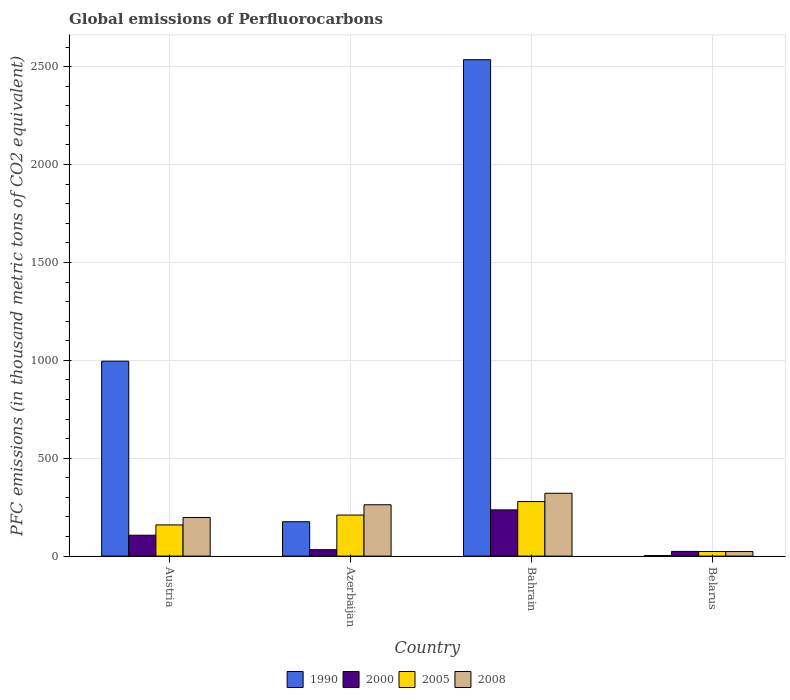Are the number of bars per tick equal to the number of legend labels?
Your answer should be very brief. Yes. How many bars are there on the 3rd tick from the right?
Your answer should be compact. 4. What is the label of the 4th group of bars from the left?
Provide a short and direct response. Belarus. In how many cases, is the number of bars for a given country not equal to the number of legend labels?
Make the answer very short. 0. What is the global emissions of Perfluorocarbons in 2008 in Azerbaijan?
Provide a short and direct response. 262.2. Across all countries, what is the maximum global emissions of Perfluorocarbons in 2008?
Offer a terse response. 320.9. Across all countries, what is the minimum global emissions of Perfluorocarbons in 2000?
Make the answer very short. 23.9. In which country was the global emissions of Perfluorocarbons in 1990 maximum?
Keep it short and to the point. Bahrain. In which country was the global emissions of Perfluorocarbons in 1990 minimum?
Provide a succinct answer. Belarus. What is the total global emissions of Perfluorocarbons in 2008 in the graph?
Ensure brevity in your answer.  803.3. What is the difference between the global emissions of Perfluorocarbons in 2008 in Azerbaijan and that in Belarus?
Keep it short and to the point. 239.1. What is the difference between the global emissions of Perfluorocarbons in 2000 in Austria and the global emissions of Perfluorocarbons in 2008 in Azerbaijan?
Your response must be concise. -155.5. What is the average global emissions of Perfluorocarbons in 2000 per country?
Provide a succinct answer. 99.88. What is the difference between the global emissions of Perfluorocarbons of/in 1990 and global emissions of Perfluorocarbons of/in 2005 in Austria?
Provide a short and direct response. 836.4. What is the ratio of the global emissions of Perfluorocarbons in 1990 in Bahrain to that in Belarus?
Your response must be concise. 975.27. Is the global emissions of Perfluorocarbons in 1990 in Azerbaijan less than that in Bahrain?
Your response must be concise. Yes. What is the difference between the highest and the second highest global emissions of Perfluorocarbons in 1990?
Your response must be concise. -820.1. What is the difference between the highest and the lowest global emissions of Perfluorocarbons in 2008?
Give a very brief answer. 297.8. Is the sum of the global emissions of Perfluorocarbons in 2008 in Austria and Bahrain greater than the maximum global emissions of Perfluorocarbons in 2005 across all countries?
Provide a succinct answer. Yes. Is it the case that in every country, the sum of the global emissions of Perfluorocarbons in 2005 and global emissions of Perfluorocarbons in 2008 is greater than the sum of global emissions of Perfluorocarbons in 2000 and global emissions of Perfluorocarbons in 1990?
Give a very brief answer. No. What does the 4th bar from the right in Azerbaijan represents?
Give a very brief answer. 1990. How many bars are there?
Provide a short and direct response. 16. What is the difference between two consecutive major ticks on the Y-axis?
Make the answer very short. 500. Does the graph contain grids?
Your answer should be very brief. Yes. How many legend labels are there?
Offer a terse response. 4. How are the legend labels stacked?
Provide a succinct answer. Horizontal. What is the title of the graph?
Offer a terse response. Global emissions of Perfluorocarbons. What is the label or title of the X-axis?
Provide a succinct answer. Country. What is the label or title of the Y-axis?
Your response must be concise. PFC emissions (in thousand metric tons of CO2 equivalent). What is the PFC emissions (in thousand metric tons of CO2 equivalent) of 1990 in Austria?
Provide a short and direct response. 995.7. What is the PFC emissions (in thousand metric tons of CO2 equivalent) in 2000 in Austria?
Offer a terse response. 106.7. What is the PFC emissions (in thousand metric tons of CO2 equivalent) of 2005 in Austria?
Offer a terse response. 159.3. What is the PFC emissions (in thousand metric tons of CO2 equivalent) in 2008 in Austria?
Your response must be concise. 197.1. What is the PFC emissions (in thousand metric tons of CO2 equivalent) of 1990 in Azerbaijan?
Offer a very short reply. 175.6. What is the PFC emissions (in thousand metric tons of CO2 equivalent) in 2000 in Azerbaijan?
Keep it short and to the point. 32.8. What is the PFC emissions (in thousand metric tons of CO2 equivalent) of 2005 in Azerbaijan?
Give a very brief answer. 209.7. What is the PFC emissions (in thousand metric tons of CO2 equivalent) of 2008 in Azerbaijan?
Your response must be concise. 262.2. What is the PFC emissions (in thousand metric tons of CO2 equivalent) of 1990 in Bahrain?
Provide a succinct answer. 2535.7. What is the PFC emissions (in thousand metric tons of CO2 equivalent) of 2000 in Bahrain?
Keep it short and to the point. 236.1. What is the PFC emissions (in thousand metric tons of CO2 equivalent) in 2005 in Bahrain?
Ensure brevity in your answer.  278.6. What is the PFC emissions (in thousand metric tons of CO2 equivalent) in 2008 in Bahrain?
Your response must be concise. 320.9. What is the PFC emissions (in thousand metric tons of CO2 equivalent) in 2000 in Belarus?
Your answer should be compact. 23.9. What is the PFC emissions (in thousand metric tons of CO2 equivalent) in 2005 in Belarus?
Give a very brief answer. 23.4. What is the PFC emissions (in thousand metric tons of CO2 equivalent) in 2008 in Belarus?
Offer a terse response. 23.1. Across all countries, what is the maximum PFC emissions (in thousand metric tons of CO2 equivalent) of 1990?
Your answer should be compact. 2535.7. Across all countries, what is the maximum PFC emissions (in thousand metric tons of CO2 equivalent) in 2000?
Keep it short and to the point. 236.1. Across all countries, what is the maximum PFC emissions (in thousand metric tons of CO2 equivalent) of 2005?
Give a very brief answer. 278.6. Across all countries, what is the maximum PFC emissions (in thousand metric tons of CO2 equivalent) in 2008?
Make the answer very short. 320.9. Across all countries, what is the minimum PFC emissions (in thousand metric tons of CO2 equivalent) in 1990?
Provide a succinct answer. 2.6. Across all countries, what is the minimum PFC emissions (in thousand metric tons of CO2 equivalent) in 2000?
Your answer should be very brief. 23.9. Across all countries, what is the minimum PFC emissions (in thousand metric tons of CO2 equivalent) in 2005?
Offer a terse response. 23.4. Across all countries, what is the minimum PFC emissions (in thousand metric tons of CO2 equivalent) in 2008?
Keep it short and to the point. 23.1. What is the total PFC emissions (in thousand metric tons of CO2 equivalent) of 1990 in the graph?
Ensure brevity in your answer.  3709.6. What is the total PFC emissions (in thousand metric tons of CO2 equivalent) in 2000 in the graph?
Your answer should be very brief. 399.5. What is the total PFC emissions (in thousand metric tons of CO2 equivalent) in 2005 in the graph?
Offer a terse response. 671. What is the total PFC emissions (in thousand metric tons of CO2 equivalent) in 2008 in the graph?
Provide a short and direct response. 803.3. What is the difference between the PFC emissions (in thousand metric tons of CO2 equivalent) of 1990 in Austria and that in Azerbaijan?
Your answer should be very brief. 820.1. What is the difference between the PFC emissions (in thousand metric tons of CO2 equivalent) in 2000 in Austria and that in Azerbaijan?
Your answer should be compact. 73.9. What is the difference between the PFC emissions (in thousand metric tons of CO2 equivalent) of 2005 in Austria and that in Azerbaijan?
Provide a succinct answer. -50.4. What is the difference between the PFC emissions (in thousand metric tons of CO2 equivalent) in 2008 in Austria and that in Azerbaijan?
Ensure brevity in your answer.  -65.1. What is the difference between the PFC emissions (in thousand metric tons of CO2 equivalent) in 1990 in Austria and that in Bahrain?
Make the answer very short. -1540. What is the difference between the PFC emissions (in thousand metric tons of CO2 equivalent) in 2000 in Austria and that in Bahrain?
Give a very brief answer. -129.4. What is the difference between the PFC emissions (in thousand metric tons of CO2 equivalent) in 2005 in Austria and that in Bahrain?
Offer a very short reply. -119.3. What is the difference between the PFC emissions (in thousand metric tons of CO2 equivalent) in 2008 in Austria and that in Bahrain?
Offer a very short reply. -123.8. What is the difference between the PFC emissions (in thousand metric tons of CO2 equivalent) in 1990 in Austria and that in Belarus?
Give a very brief answer. 993.1. What is the difference between the PFC emissions (in thousand metric tons of CO2 equivalent) of 2000 in Austria and that in Belarus?
Ensure brevity in your answer.  82.8. What is the difference between the PFC emissions (in thousand metric tons of CO2 equivalent) in 2005 in Austria and that in Belarus?
Your answer should be very brief. 135.9. What is the difference between the PFC emissions (in thousand metric tons of CO2 equivalent) in 2008 in Austria and that in Belarus?
Make the answer very short. 174. What is the difference between the PFC emissions (in thousand metric tons of CO2 equivalent) in 1990 in Azerbaijan and that in Bahrain?
Keep it short and to the point. -2360.1. What is the difference between the PFC emissions (in thousand metric tons of CO2 equivalent) in 2000 in Azerbaijan and that in Bahrain?
Ensure brevity in your answer.  -203.3. What is the difference between the PFC emissions (in thousand metric tons of CO2 equivalent) in 2005 in Azerbaijan and that in Bahrain?
Offer a very short reply. -68.9. What is the difference between the PFC emissions (in thousand metric tons of CO2 equivalent) in 2008 in Azerbaijan and that in Bahrain?
Your answer should be compact. -58.7. What is the difference between the PFC emissions (in thousand metric tons of CO2 equivalent) in 1990 in Azerbaijan and that in Belarus?
Give a very brief answer. 173. What is the difference between the PFC emissions (in thousand metric tons of CO2 equivalent) of 2000 in Azerbaijan and that in Belarus?
Keep it short and to the point. 8.9. What is the difference between the PFC emissions (in thousand metric tons of CO2 equivalent) in 2005 in Azerbaijan and that in Belarus?
Your answer should be very brief. 186.3. What is the difference between the PFC emissions (in thousand metric tons of CO2 equivalent) in 2008 in Azerbaijan and that in Belarus?
Ensure brevity in your answer.  239.1. What is the difference between the PFC emissions (in thousand metric tons of CO2 equivalent) of 1990 in Bahrain and that in Belarus?
Make the answer very short. 2533.1. What is the difference between the PFC emissions (in thousand metric tons of CO2 equivalent) in 2000 in Bahrain and that in Belarus?
Provide a short and direct response. 212.2. What is the difference between the PFC emissions (in thousand metric tons of CO2 equivalent) of 2005 in Bahrain and that in Belarus?
Give a very brief answer. 255.2. What is the difference between the PFC emissions (in thousand metric tons of CO2 equivalent) of 2008 in Bahrain and that in Belarus?
Keep it short and to the point. 297.8. What is the difference between the PFC emissions (in thousand metric tons of CO2 equivalent) of 1990 in Austria and the PFC emissions (in thousand metric tons of CO2 equivalent) of 2000 in Azerbaijan?
Your response must be concise. 962.9. What is the difference between the PFC emissions (in thousand metric tons of CO2 equivalent) in 1990 in Austria and the PFC emissions (in thousand metric tons of CO2 equivalent) in 2005 in Azerbaijan?
Your response must be concise. 786. What is the difference between the PFC emissions (in thousand metric tons of CO2 equivalent) in 1990 in Austria and the PFC emissions (in thousand metric tons of CO2 equivalent) in 2008 in Azerbaijan?
Provide a short and direct response. 733.5. What is the difference between the PFC emissions (in thousand metric tons of CO2 equivalent) of 2000 in Austria and the PFC emissions (in thousand metric tons of CO2 equivalent) of 2005 in Azerbaijan?
Offer a very short reply. -103. What is the difference between the PFC emissions (in thousand metric tons of CO2 equivalent) of 2000 in Austria and the PFC emissions (in thousand metric tons of CO2 equivalent) of 2008 in Azerbaijan?
Your answer should be compact. -155.5. What is the difference between the PFC emissions (in thousand metric tons of CO2 equivalent) of 2005 in Austria and the PFC emissions (in thousand metric tons of CO2 equivalent) of 2008 in Azerbaijan?
Give a very brief answer. -102.9. What is the difference between the PFC emissions (in thousand metric tons of CO2 equivalent) in 1990 in Austria and the PFC emissions (in thousand metric tons of CO2 equivalent) in 2000 in Bahrain?
Ensure brevity in your answer.  759.6. What is the difference between the PFC emissions (in thousand metric tons of CO2 equivalent) in 1990 in Austria and the PFC emissions (in thousand metric tons of CO2 equivalent) in 2005 in Bahrain?
Make the answer very short. 717.1. What is the difference between the PFC emissions (in thousand metric tons of CO2 equivalent) of 1990 in Austria and the PFC emissions (in thousand metric tons of CO2 equivalent) of 2008 in Bahrain?
Give a very brief answer. 674.8. What is the difference between the PFC emissions (in thousand metric tons of CO2 equivalent) in 2000 in Austria and the PFC emissions (in thousand metric tons of CO2 equivalent) in 2005 in Bahrain?
Your answer should be very brief. -171.9. What is the difference between the PFC emissions (in thousand metric tons of CO2 equivalent) of 2000 in Austria and the PFC emissions (in thousand metric tons of CO2 equivalent) of 2008 in Bahrain?
Ensure brevity in your answer.  -214.2. What is the difference between the PFC emissions (in thousand metric tons of CO2 equivalent) in 2005 in Austria and the PFC emissions (in thousand metric tons of CO2 equivalent) in 2008 in Bahrain?
Provide a short and direct response. -161.6. What is the difference between the PFC emissions (in thousand metric tons of CO2 equivalent) of 1990 in Austria and the PFC emissions (in thousand metric tons of CO2 equivalent) of 2000 in Belarus?
Provide a succinct answer. 971.8. What is the difference between the PFC emissions (in thousand metric tons of CO2 equivalent) in 1990 in Austria and the PFC emissions (in thousand metric tons of CO2 equivalent) in 2005 in Belarus?
Ensure brevity in your answer.  972.3. What is the difference between the PFC emissions (in thousand metric tons of CO2 equivalent) in 1990 in Austria and the PFC emissions (in thousand metric tons of CO2 equivalent) in 2008 in Belarus?
Give a very brief answer. 972.6. What is the difference between the PFC emissions (in thousand metric tons of CO2 equivalent) of 2000 in Austria and the PFC emissions (in thousand metric tons of CO2 equivalent) of 2005 in Belarus?
Ensure brevity in your answer.  83.3. What is the difference between the PFC emissions (in thousand metric tons of CO2 equivalent) of 2000 in Austria and the PFC emissions (in thousand metric tons of CO2 equivalent) of 2008 in Belarus?
Your answer should be compact. 83.6. What is the difference between the PFC emissions (in thousand metric tons of CO2 equivalent) of 2005 in Austria and the PFC emissions (in thousand metric tons of CO2 equivalent) of 2008 in Belarus?
Ensure brevity in your answer.  136.2. What is the difference between the PFC emissions (in thousand metric tons of CO2 equivalent) of 1990 in Azerbaijan and the PFC emissions (in thousand metric tons of CO2 equivalent) of 2000 in Bahrain?
Provide a short and direct response. -60.5. What is the difference between the PFC emissions (in thousand metric tons of CO2 equivalent) of 1990 in Azerbaijan and the PFC emissions (in thousand metric tons of CO2 equivalent) of 2005 in Bahrain?
Offer a very short reply. -103. What is the difference between the PFC emissions (in thousand metric tons of CO2 equivalent) in 1990 in Azerbaijan and the PFC emissions (in thousand metric tons of CO2 equivalent) in 2008 in Bahrain?
Keep it short and to the point. -145.3. What is the difference between the PFC emissions (in thousand metric tons of CO2 equivalent) in 2000 in Azerbaijan and the PFC emissions (in thousand metric tons of CO2 equivalent) in 2005 in Bahrain?
Keep it short and to the point. -245.8. What is the difference between the PFC emissions (in thousand metric tons of CO2 equivalent) of 2000 in Azerbaijan and the PFC emissions (in thousand metric tons of CO2 equivalent) of 2008 in Bahrain?
Your answer should be compact. -288.1. What is the difference between the PFC emissions (in thousand metric tons of CO2 equivalent) in 2005 in Azerbaijan and the PFC emissions (in thousand metric tons of CO2 equivalent) in 2008 in Bahrain?
Make the answer very short. -111.2. What is the difference between the PFC emissions (in thousand metric tons of CO2 equivalent) of 1990 in Azerbaijan and the PFC emissions (in thousand metric tons of CO2 equivalent) of 2000 in Belarus?
Provide a succinct answer. 151.7. What is the difference between the PFC emissions (in thousand metric tons of CO2 equivalent) in 1990 in Azerbaijan and the PFC emissions (in thousand metric tons of CO2 equivalent) in 2005 in Belarus?
Provide a short and direct response. 152.2. What is the difference between the PFC emissions (in thousand metric tons of CO2 equivalent) in 1990 in Azerbaijan and the PFC emissions (in thousand metric tons of CO2 equivalent) in 2008 in Belarus?
Offer a terse response. 152.5. What is the difference between the PFC emissions (in thousand metric tons of CO2 equivalent) of 2000 in Azerbaijan and the PFC emissions (in thousand metric tons of CO2 equivalent) of 2005 in Belarus?
Offer a terse response. 9.4. What is the difference between the PFC emissions (in thousand metric tons of CO2 equivalent) in 2000 in Azerbaijan and the PFC emissions (in thousand metric tons of CO2 equivalent) in 2008 in Belarus?
Make the answer very short. 9.7. What is the difference between the PFC emissions (in thousand metric tons of CO2 equivalent) of 2005 in Azerbaijan and the PFC emissions (in thousand metric tons of CO2 equivalent) of 2008 in Belarus?
Provide a short and direct response. 186.6. What is the difference between the PFC emissions (in thousand metric tons of CO2 equivalent) in 1990 in Bahrain and the PFC emissions (in thousand metric tons of CO2 equivalent) in 2000 in Belarus?
Keep it short and to the point. 2511.8. What is the difference between the PFC emissions (in thousand metric tons of CO2 equivalent) in 1990 in Bahrain and the PFC emissions (in thousand metric tons of CO2 equivalent) in 2005 in Belarus?
Keep it short and to the point. 2512.3. What is the difference between the PFC emissions (in thousand metric tons of CO2 equivalent) in 1990 in Bahrain and the PFC emissions (in thousand metric tons of CO2 equivalent) in 2008 in Belarus?
Your response must be concise. 2512.6. What is the difference between the PFC emissions (in thousand metric tons of CO2 equivalent) in 2000 in Bahrain and the PFC emissions (in thousand metric tons of CO2 equivalent) in 2005 in Belarus?
Provide a short and direct response. 212.7. What is the difference between the PFC emissions (in thousand metric tons of CO2 equivalent) of 2000 in Bahrain and the PFC emissions (in thousand metric tons of CO2 equivalent) of 2008 in Belarus?
Your answer should be very brief. 213. What is the difference between the PFC emissions (in thousand metric tons of CO2 equivalent) in 2005 in Bahrain and the PFC emissions (in thousand metric tons of CO2 equivalent) in 2008 in Belarus?
Your response must be concise. 255.5. What is the average PFC emissions (in thousand metric tons of CO2 equivalent) of 1990 per country?
Keep it short and to the point. 927.4. What is the average PFC emissions (in thousand metric tons of CO2 equivalent) in 2000 per country?
Make the answer very short. 99.88. What is the average PFC emissions (in thousand metric tons of CO2 equivalent) in 2005 per country?
Offer a terse response. 167.75. What is the average PFC emissions (in thousand metric tons of CO2 equivalent) in 2008 per country?
Offer a very short reply. 200.82. What is the difference between the PFC emissions (in thousand metric tons of CO2 equivalent) in 1990 and PFC emissions (in thousand metric tons of CO2 equivalent) in 2000 in Austria?
Your answer should be very brief. 889. What is the difference between the PFC emissions (in thousand metric tons of CO2 equivalent) of 1990 and PFC emissions (in thousand metric tons of CO2 equivalent) of 2005 in Austria?
Offer a very short reply. 836.4. What is the difference between the PFC emissions (in thousand metric tons of CO2 equivalent) in 1990 and PFC emissions (in thousand metric tons of CO2 equivalent) in 2008 in Austria?
Make the answer very short. 798.6. What is the difference between the PFC emissions (in thousand metric tons of CO2 equivalent) of 2000 and PFC emissions (in thousand metric tons of CO2 equivalent) of 2005 in Austria?
Your response must be concise. -52.6. What is the difference between the PFC emissions (in thousand metric tons of CO2 equivalent) in 2000 and PFC emissions (in thousand metric tons of CO2 equivalent) in 2008 in Austria?
Ensure brevity in your answer.  -90.4. What is the difference between the PFC emissions (in thousand metric tons of CO2 equivalent) in 2005 and PFC emissions (in thousand metric tons of CO2 equivalent) in 2008 in Austria?
Ensure brevity in your answer.  -37.8. What is the difference between the PFC emissions (in thousand metric tons of CO2 equivalent) of 1990 and PFC emissions (in thousand metric tons of CO2 equivalent) of 2000 in Azerbaijan?
Your response must be concise. 142.8. What is the difference between the PFC emissions (in thousand metric tons of CO2 equivalent) of 1990 and PFC emissions (in thousand metric tons of CO2 equivalent) of 2005 in Azerbaijan?
Make the answer very short. -34.1. What is the difference between the PFC emissions (in thousand metric tons of CO2 equivalent) in 1990 and PFC emissions (in thousand metric tons of CO2 equivalent) in 2008 in Azerbaijan?
Keep it short and to the point. -86.6. What is the difference between the PFC emissions (in thousand metric tons of CO2 equivalent) in 2000 and PFC emissions (in thousand metric tons of CO2 equivalent) in 2005 in Azerbaijan?
Keep it short and to the point. -176.9. What is the difference between the PFC emissions (in thousand metric tons of CO2 equivalent) of 2000 and PFC emissions (in thousand metric tons of CO2 equivalent) of 2008 in Azerbaijan?
Provide a short and direct response. -229.4. What is the difference between the PFC emissions (in thousand metric tons of CO2 equivalent) in 2005 and PFC emissions (in thousand metric tons of CO2 equivalent) in 2008 in Azerbaijan?
Offer a terse response. -52.5. What is the difference between the PFC emissions (in thousand metric tons of CO2 equivalent) in 1990 and PFC emissions (in thousand metric tons of CO2 equivalent) in 2000 in Bahrain?
Your response must be concise. 2299.6. What is the difference between the PFC emissions (in thousand metric tons of CO2 equivalent) of 1990 and PFC emissions (in thousand metric tons of CO2 equivalent) of 2005 in Bahrain?
Make the answer very short. 2257.1. What is the difference between the PFC emissions (in thousand metric tons of CO2 equivalent) of 1990 and PFC emissions (in thousand metric tons of CO2 equivalent) of 2008 in Bahrain?
Provide a short and direct response. 2214.8. What is the difference between the PFC emissions (in thousand metric tons of CO2 equivalent) in 2000 and PFC emissions (in thousand metric tons of CO2 equivalent) in 2005 in Bahrain?
Offer a terse response. -42.5. What is the difference between the PFC emissions (in thousand metric tons of CO2 equivalent) of 2000 and PFC emissions (in thousand metric tons of CO2 equivalent) of 2008 in Bahrain?
Your answer should be very brief. -84.8. What is the difference between the PFC emissions (in thousand metric tons of CO2 equivalent) in 2005 and PFC emissions (in thousand metric tons of CO2 equivalent) in 2008 in Bahrain?
Provide a short and direct response. -42.3. What is the difference between the PFC emissions (in thousand metric tons of CO2 equivalent) in 1990 and PFC emissions (in thousand metric tons of CO2 equivalent) in 2000 in Belarus?
Your response must be concise. -21.3. What is the difference between the PFC emissions (in thousand metric tons of CO2 equivalent) of 1990 and PFC emissions (in thousand metric tons of CO2 equivalent) of 2005 in Belarus?
Offer a terse response. -20.8. What is the difference between the PFC emissions (in thousand metric tons of CO2 equivalent) in 1990 and PFC emissions (in thousand metric tons of CO2 equivalent) in 2008 in Belarus?
Offer a very short reply. -20.5. What is the difference between the PFC emissions (in thousand metric tons of CO2 equivalent) in 2005 and PFC emissions (in thousand metric tons of CO2 equivalent) in 2008 in Belarus?
Provide a succinct answer. 0.3. What is the ratio of the PFC emissions (in thousand metric tons of CO2 equivalent) of 1990 in Austria to that in Azerbaijan?
Offer a terse response. 5.67. What is the ratio of the PFC emissions (in thousand metric tons of CO2 equivalent) of 2000 in Austria to that in Azerbaijan?
Provide a succinct answer. 3.25. What is the ratio of the PFC emissions (in thousand metric tons of CO2 equivalent) in 2005 in Austria to that in Azerbaijan?
Offer a terse response. 0.76. What is the ratio of the PFC emissions (in thousand metric tons of CO2 equivalent) of 2008 in Austria to that in Azerbaijan?
Provide a succinct answer. 0.75. What is the ratio of the PFC emissions (in thousand metric tons of CO2 equivalent) of 1990 in Austria to that in Bahrain?
Provide a succinct answer. 0.39. What is the ratio of the PFC emissions (in thousand metric tons of CO2 equivalent) of 2000 in Austria to that in Bahrain?
Offer a very short reply. 0.45. What is the ratio of the PFC emissions (in thousand metric tons of CO2 equivalent) of 2005 in Austria to that in Bahrain?
Provide a short and direct response. 0.57. What is the ratio of the PFC emissions (in thousand metric tons of CO2 equivalent) of 2008 in Austria to that in Bahrain?
Provide a succinct answer. 0.61. What is the ratio of the PFC emissions (in thousand metric tons of CO2 equivalent) of 1990 in Austria to that in Belarus?
Provide a short and direct response. 382.96. What is the ratio of the PFC emissions (in thousand metric tons of CO2 equivalent) in 2000 in Austria to that in Belarus?
Ensure brevity in your answer.  4.46. What is the ratio of the PFC emissions (in thousand metric tons of CO2 equivalent) of 2005 in Austria to that in Belarus?
Provide a succinct answer. 6.81. What is the ratio of the PFC emissions (in thousand metric tons of CO2 equivalent) of 2008 in Austria to that in Belarus?
Make the answer very short. 8.53. What is the ratio of the PFC emissions (in thousand metric tons of CO2 equivalent) in 1990 in Azerbaijan to that in Bahrain?
Keep it short and to the point. 0.07. What is the ratio of the PFC emissions (in thousand metric tons of CO2 equivalent) of 2000 in Azerbaijan to that in Bahrain?
Offer a very short reply. 0.14. What is the ratio of the PFC emissions (in thousand metric tons of CO2 equivalent) in 2005 in Azerbaijan to that in Bahrain?
Give a very brief answer. 0.75. What is the ratio of the PFC emissions (in thousand metric tons of CO2 equivalent) in 2008 in Azerbaijan to that in Bahrain?
Your answer should be compact. 0.82. What is the ratio of the PFC emissions (in thousand metric tons of CO2 equivalent) in 1990 in Azerbaijan to that in Belarus?
Your response must be concise. 67.54. What is the ratio of the PFC emissions (in thousand metric tons of CO2 equivalent) of 2000 in Azerbaijan to that in Belarus?
Ensure brevity in your answer.  1.37. What is the ratio of the PFC emissions (in thousand metric tons of CO2 equivalent) of 2005 in Azerbaijan to that in Belarus?
Ensure brevity in your answer.  8.96. What is the ratio of the PFC emissions (in thousand metric tons of CO2 equivalent) of 2008 in Azerbaijan to that in Belarus?
Provide a succinct answer. 11.35. What is the ratio of the PFC emissions (in thousand metric tons of CO2 equivalent) in 1990 in Bahrain to that in Belarus?
Keep it short and to the point. 975.27. What is the ratio of the PFC emissions (in thousand metric tons of CO2 equivalent) of 2000 in Bahrain to that in Belarus?
Keep it short and to the point. 9.88. What is the ratio of the PFC emissions (in thousand metric tons of CO2 equivalent) of 2005 in Bahrain to that in Belarus?
Give a very brief answer. 11.91. What is the ratio of the PFC emissions (in thousand metric tons of CO2 equivalent) in 2008 in Bahrain to that in Belarus?
Make the answer very short. 13.89. What is the difference between the highest and the second highest PFC emissions (in thousand metric tons of CO2 equivalent) in 1990?
Your answer should be compact. 1540. What is the difference between the highest and the second highest PFC emissions (in thousand metric tons of CO2 equivalent) in 2000?
Your answer should be very brief. 129.4. What is the difference between the highest and the second highest PFC emissions (in thousand metric tons of CO2 equivalent) in 2005?
Provide a short and direct response. 68.9. What is the difference between the highest and the second highest PFC emissions (in thousand metric tons of CO2 equivalent) of 2008?
Your answer should be very brief. 58.7. What is the difference between the highest and the lowest PFC emissions (in thousand metric tons of CO2 equivalent) in 1990?
Provide a short and direct response. 2533.1. What is the difference between the highest and the lowest PFC emissions (in thousand metric tons of CO2 equivalent) of 2000?
Ensure brevity in your answer.  212.2. What is the difference between the highest and the lowest PFC emissions (in thousand metric tons of CO2 equivalent) in 2005?
Make the answer very short. 255.2. What is the difference between the highest and the lowest PFC emissions (in thousand metric tons of CO2 equivalent) in 2008?
Give a very brief answer. 297.8. 